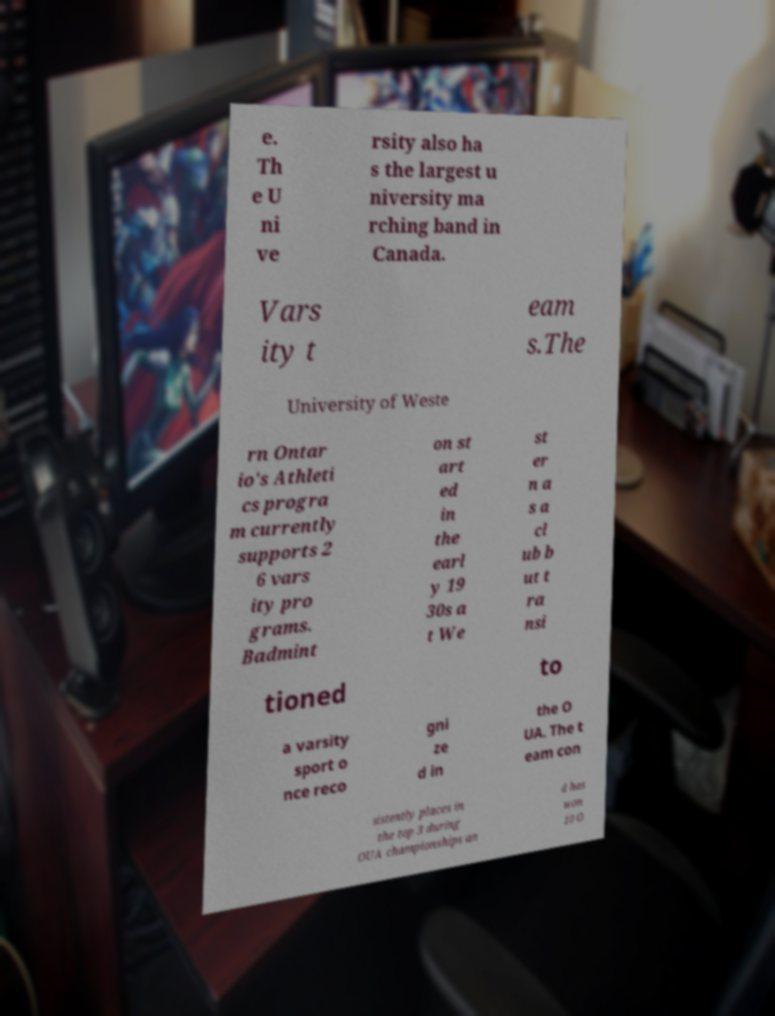For documentation purposes, I need the text within this image transcribed. Could you provide that? e. Th e U ni ve rsity also ha s the largest u niversity ma rching band in Canada. Vars ity t eam s.The University of Weste rn Ontar io's Athleti cs progra m currently supports 2 6 vars ity pro grams. Badmint on st art ed in the earl y 19 30s a t We st er n a s a cl ub b ut t ra nsi tioned to a varsity sport o nce reco gni ze d in the O UA. The t eam con sistently places in the top 3 during OUA championships an d has won 10 O 